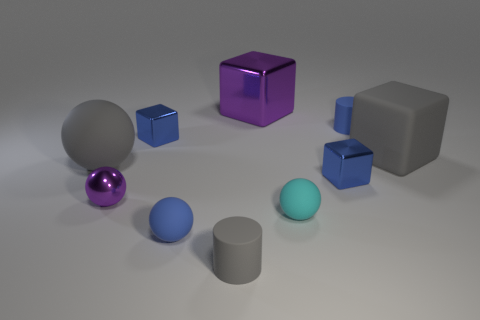Which shapes in the image are the same color? The sphere and the cylinder in the foreground share the same hue of light blue. 